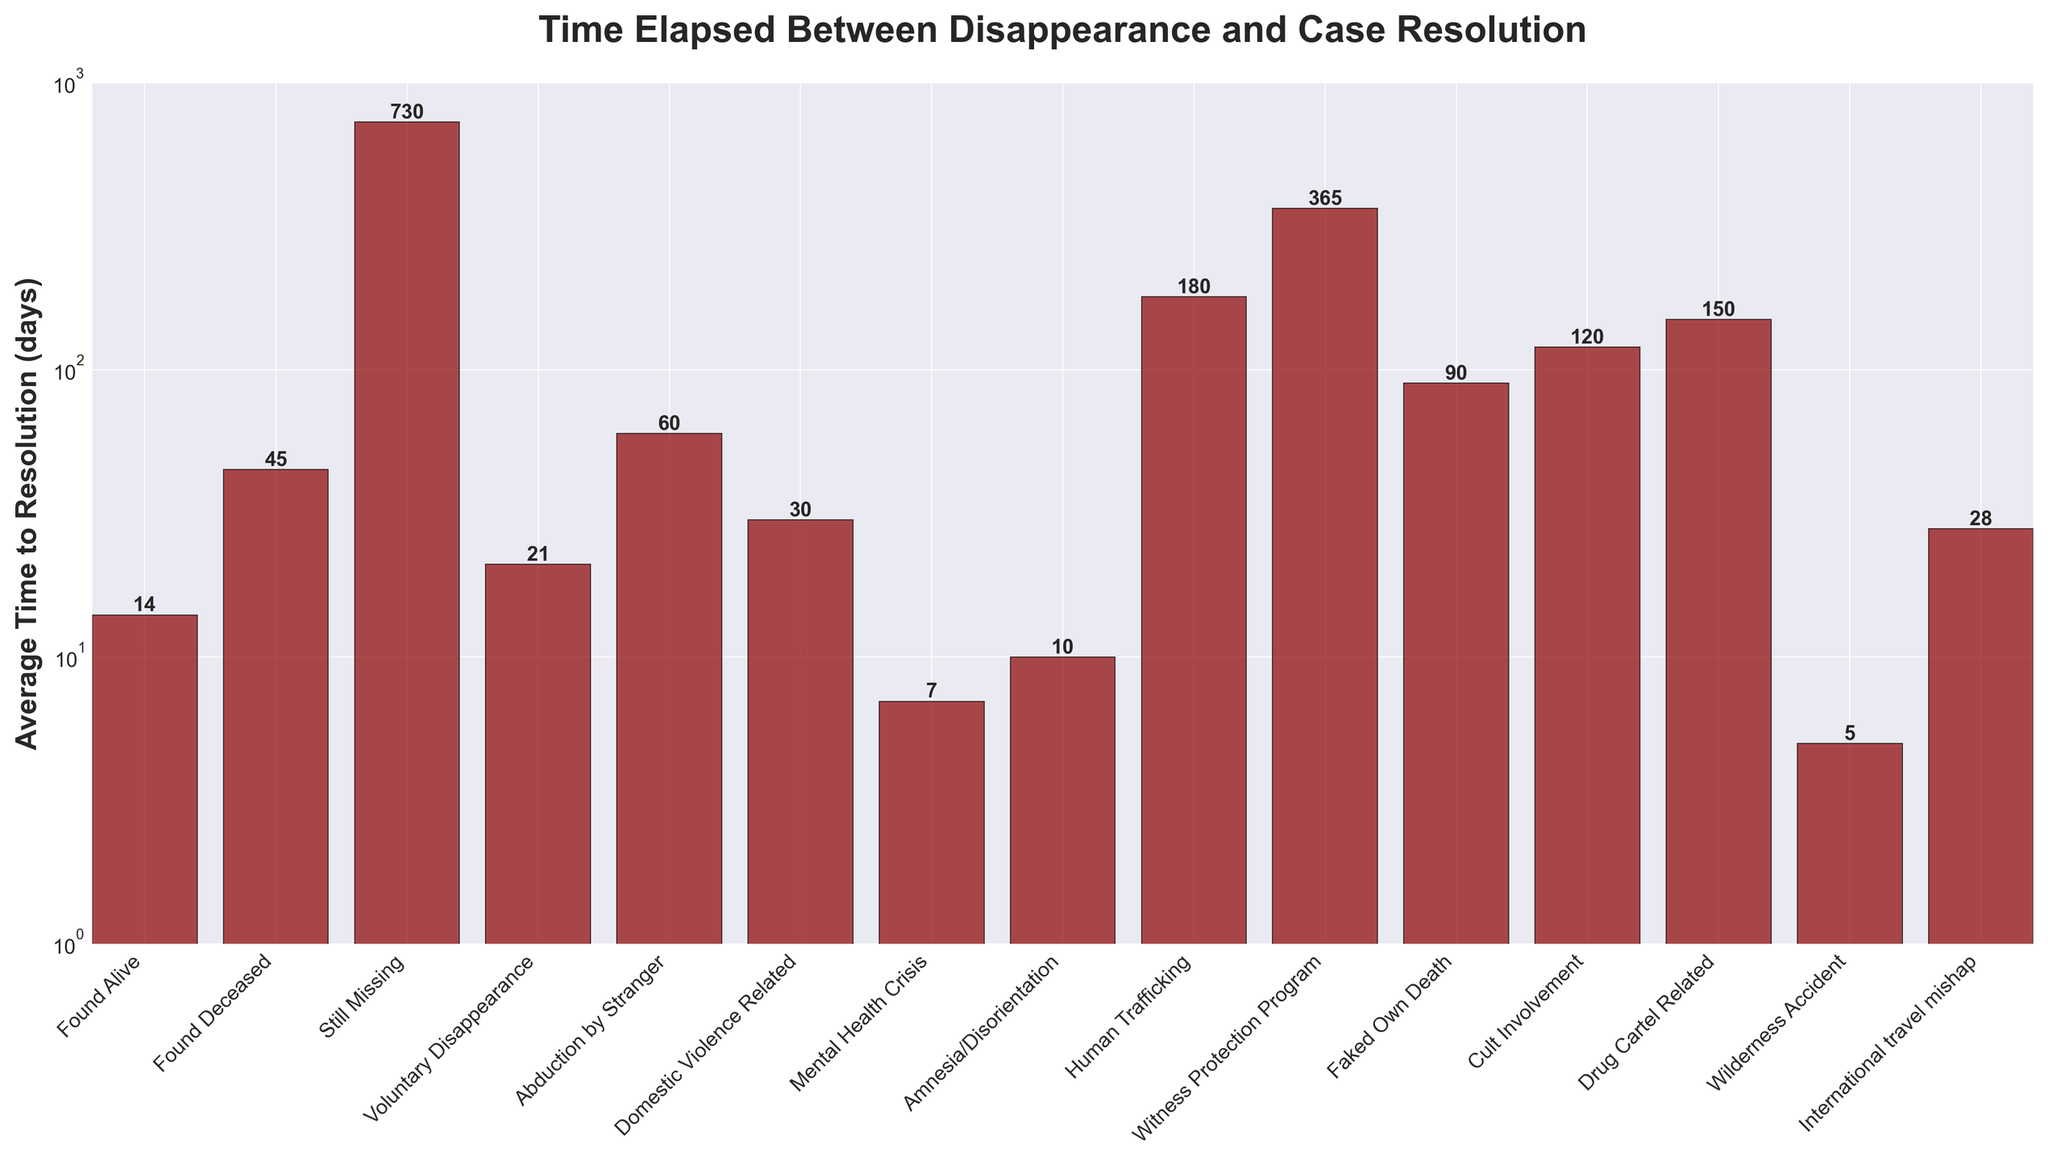How many outcomes have an average time to resolution greater than 50 days? First, identify the bars with heights representing values greater than 50 days. These outcomes are "Abduction by Stranger," "Human Trafficking," "Witness Protection Program," "Faked Own Death," "Cult Involvement," and "Drug Cartel Related." Count them.
Answer: 6 Of the outcomes categorized under "Found Alive," "Found Deceased," and "Still Missing," which has the longest average time to resolution? Among "Found Alive" (14 days), "Found Deceased" (45 days), and "Still Missing" (730 days), "Still Missing" has the longest average time to resolution.
Answer: Still Missing What is the difference in average time to resolution between "Found Alive" and "Found Deceased"? "Found Alive" has an average of 14 days and "Found Deceased" has an average of 45 days. Subtract the smaller value from the larger: 45 - 14 = 31 days.
Answer: 31 Which outcome has the shortest average time to resolution, and how many days does it take? Identify the bar with the smallest height, which is "Wilderness Accident" at 5 days.
Answer: Wilderness Accident, 5 What is the average time to resolution for outcomes involving mental health crises and wilderness accidents combined? Sum the average times for "Mental Health Crisis" (7 days) and "Wilderness Accident" (5 days), then divide by 2: (7 + 5) / 2 = 6 days.
Answer: 6 How many outcomes have an average time to resolution less than or equal to 30 days? Identify the bars with heights of 30 days or less: "Found Alive" (14), "Voluntary Disappearance" (21), "Mental Health Crisis" (7), "Amnesia/Disorientation" (10), and "Wilderness Accident" (5). Count them.
Answer: 5 Compare the average times to resolution for "Human Trafficking" and "Drug Cartel Related." Which is higher and by how much? "Human Trafficking" has an average of 180 days and "Drug Cartel Related" has 150 days. Subtract: 180 - 150 = 30 days. "Human Trafficking" is higher by 30 days.
Answer: Human Trafficking, 30 What is the mean average time to resolution for "Abduction by Stranger," "Domestic Violence Related," and "International travel mishap"? Sum the average times and divide by 3: (60 + 30 + 28) / 3 = 39.33 days.
Answer: 39.33 Which outcome related to a crisis has the lowest average time to resolution? Among "Mental Health Crisis" (7 days) and "Amnesia/Disorientation" (10 days), "Mental Health Crisis" has the lowest average time to resolution.
Answer: Mental Health Crisis By how many days does "Cult Involvement" exceed the average time to resolution of "Voluntary Disappearance"? "Cult Involvement" has 120 days, and "Voluntary Disappearance" has 21 days. Subtract: 120 - 21 = 99 days.
Answer: 99 